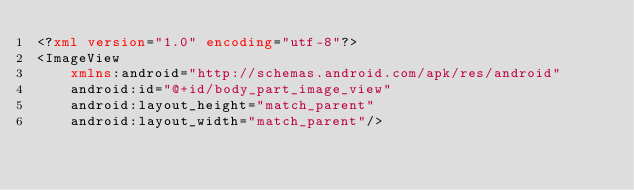<code> <loc_0><loc_0><loc_500><loc_500><_XML_><?xml version="1.0" encoding="utf-8"?>
<ImageView
    xmlns:android="http://schemas.android.com/apk/res/android"
    android:id="@+id/body_part_image_view"
    android:layout_height="match_parent"
    android:layout_width="match_parent"/></code> 